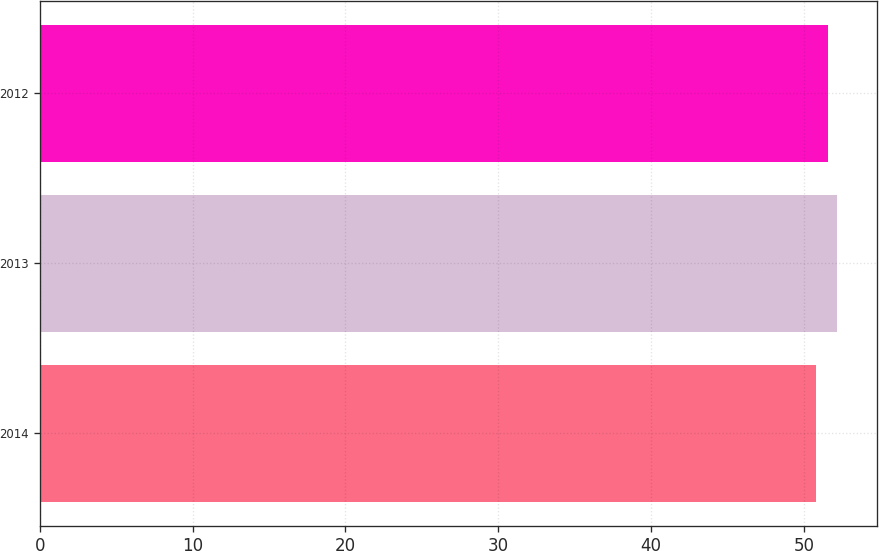<chart> <loc_0><loc_0><loc_500><loc_500><bar_chart><fcel>2014<fcel>2013<fcel>2012<nl><fcel>50.8<fcel>52.2<fcel>51.6<nl></chart> 